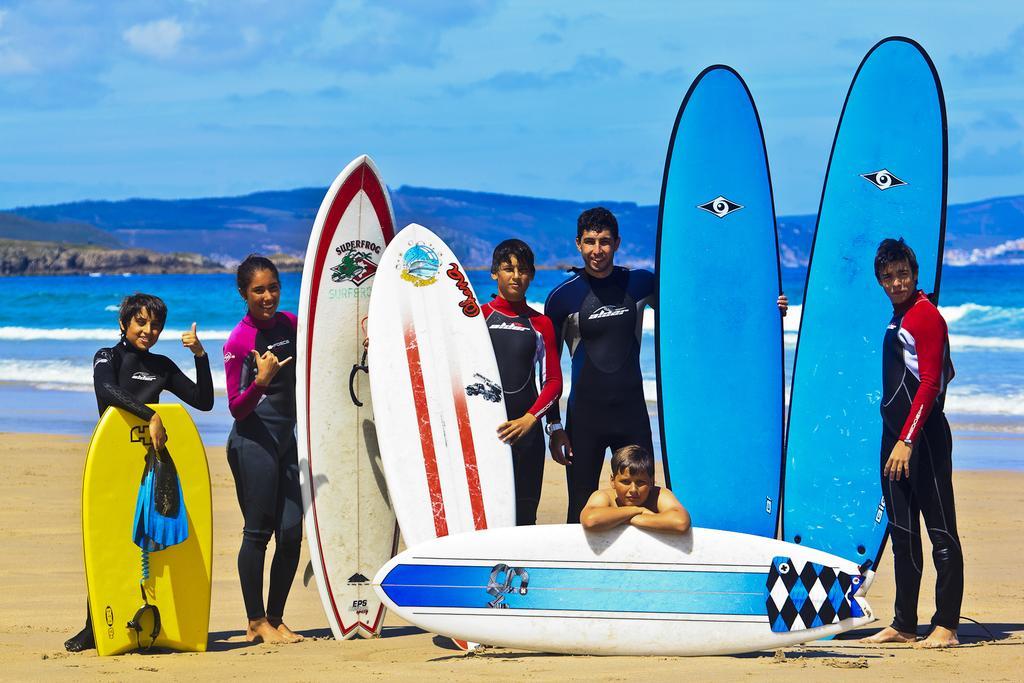Please provide a concise description of this image. In the image we can see there are people standing near the sea shore and they are holding surfing board in their hand. Behind there is an ocean and there is a clear sky. 